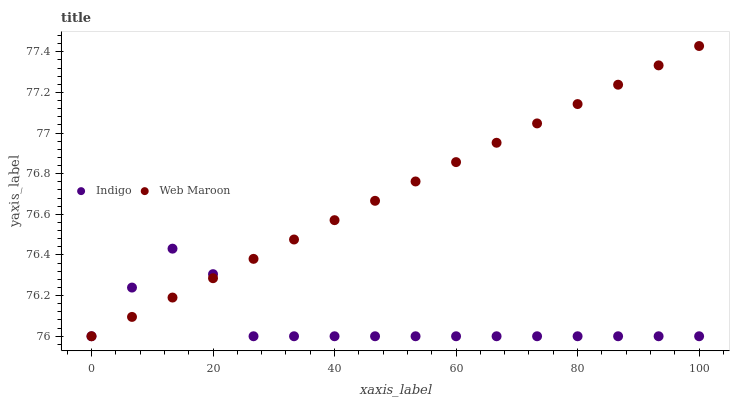Does Indigo have the minimum area under the curve?
Answer yes or no. Yes. Does Web Maroon have the maximum area under the curve?
Answer yes or no. Yes. Does Indigo have the maximum area under the curve?
Answer yes or no. No. Is Web Maroon the smoothest?
Answer yes or no. Yes. Is Indigo the roughest?
Answer yes or no. Yes. Is Indigo the smoothest?
Answer yes or no. No. Does Web Maroon have the lowest value?
Answer yes or no. Yes. Does Web Maroon have the highest value?
Answer yes or no. Yes. Does Indigo have the highest value?
Answer yes or no. No. Does Web Maroon intersect Indigo?
Answer yes or no. Yes. Is Web Maroon less than Indigo?
Answer yes or no. No. Is Web Maroon greater than Indigo?
Answer yes or no. No. 